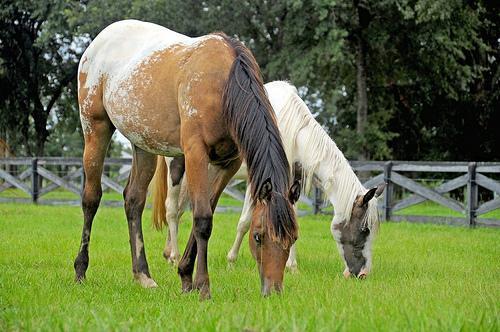How many horses are there?
Give a very brief answer. 2. How many horses are there in the picture?
Give a very brief answer. 2. 